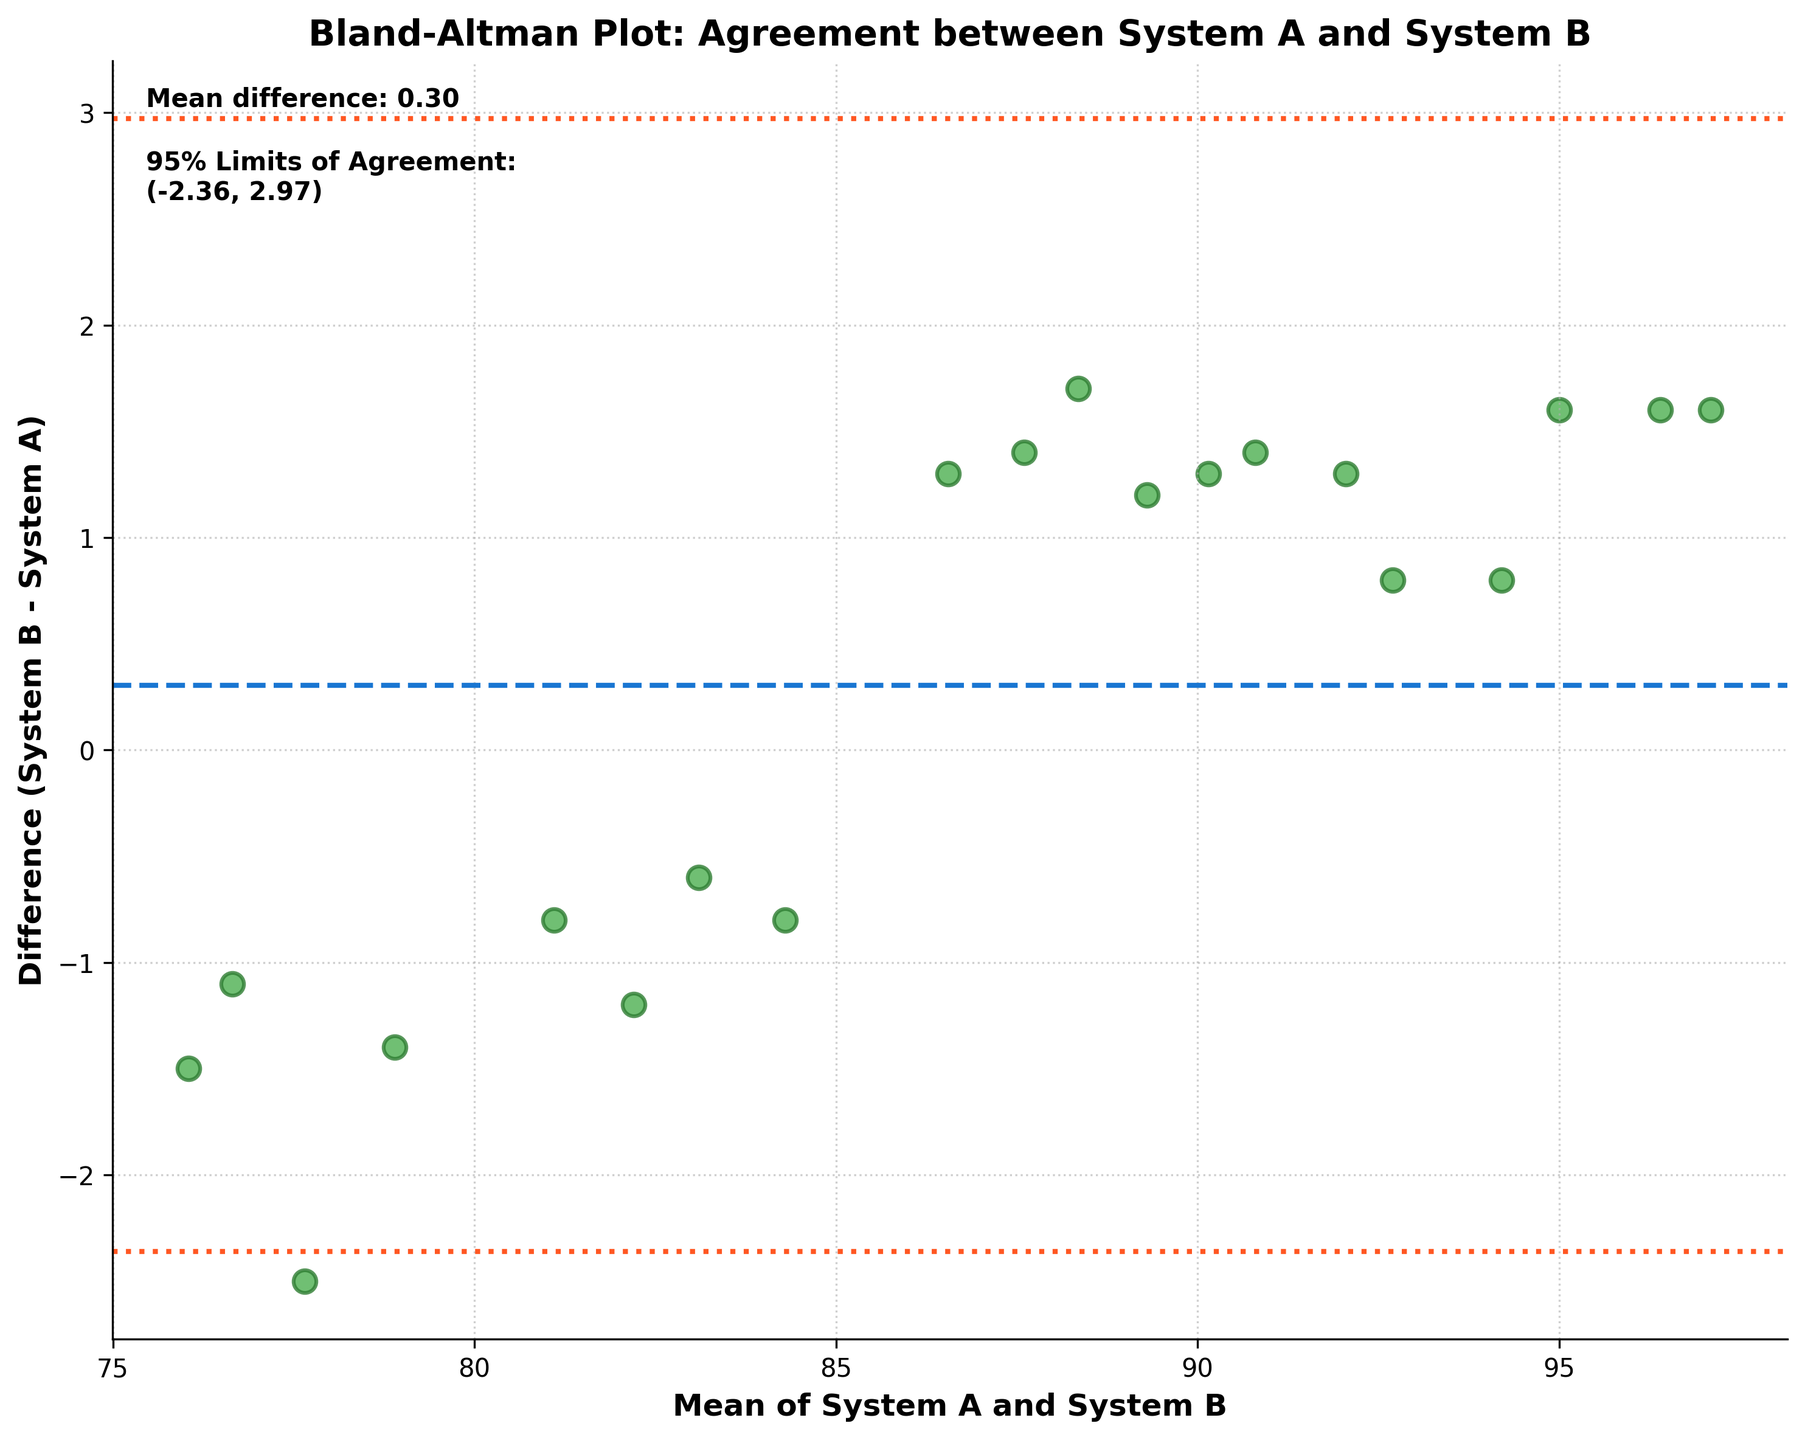What does the title of the Bland-Altman plot tell us? The title of the figure states "Bland-Altman Plot: Agreement between System A and System B", indicating that the plot is used to analyze the agreement between two software systems for calculating employee performance scores.
Answer: Agreement between System A and System B How many data points are displayed in the Bland-Altman plot? By counting the points on the plot, we can determine the total number of data points present.
Answer: 20 What does the horizontal blue dashed line in the plot represent? The horizontal blue dashed line represents the mean difference between the two systems’ scores.
Answer: Mean difference What is the mean difference between the two systems' scores? The mean difference is explicitly labeled on the plot as "Mean difference: 0.70".
Answer: 0.70 What do the dotted orange lines on the plot represent? These dotted orange lines represent the 95% limits of agreement.
Answer: 95% limits of agreement What are the values for the 95% limits of agreement? The 95% limits of agreement are labeled on the plot as (-1.84, 3.24).
Answer: -1.84, 3.24 What is the range covered by the 95% limits of agreement? The range can be calculated by subtracting the lower limit from the upper limit: 3.24 - (-1.84) = 5.08.
Answer: 5.08 On the plot, how many data points fall outside the 95% limits of agreement? By observing the plot, we can identify and count data points that are above or below the dotted orange lines.
Answer: 0 What does the x-axis of the Bland-Altman plot represent? The x-axis is labeled "Mean of System A and System B", which indicates the average score from both systems for each data point.
Answer: Mean of System A and System B What does the y-axis of the Bland-Altman plot represent? The y-axis is labeled "Difference (System B - System A)", showing the difference in scores between System B and System A for each data point.
Answer: Difference (System B - System A) 